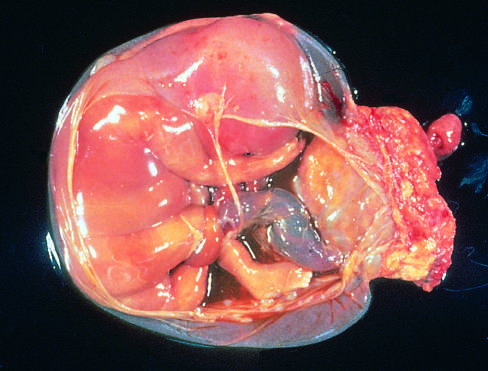what does the band of amnion extend from?
Answer the question using a single word or phrase. The portion of the amniotic sac to encircle the leg of the fetus 